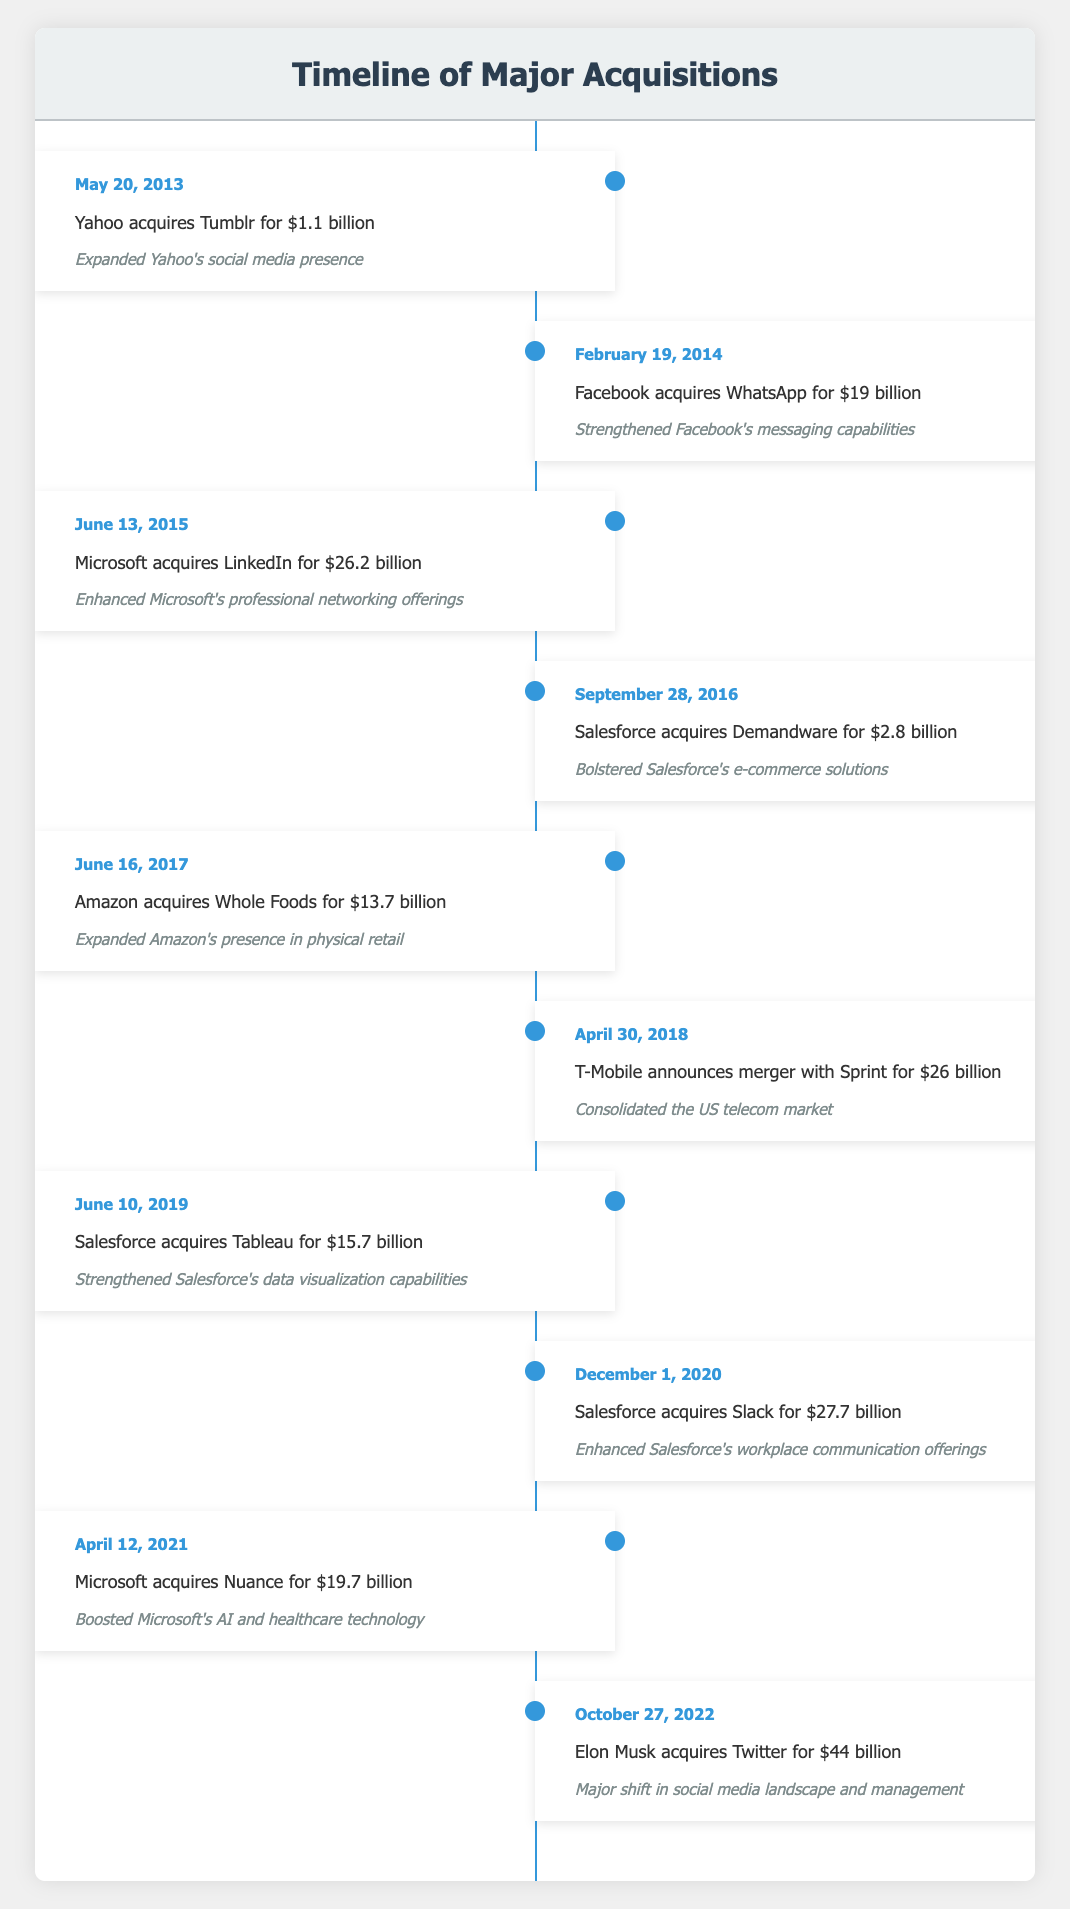What was the highest acquisition value listed in the table? The highest acquisition value is $44 billion, associated with Elon Musk's acquisition of Twitter on October 27, 2022. This information is directly retrieved from the 'event' entry for that specific date.
Answer: $44 billion Which company acquired LinkedIn, and what was the acquisition's date? Microsoft acquired LinkedIn on June 13, 2015. This information can be found by locating the row with LinkedIn in the 'event' column and noting the corresponding 'date' value.
Answer: Microsoft, June 13, 2015 How many acquisitions listed took place in 2020 or later? There are three acquisitions from 2020 onwards: Salesforce acquired Slack for $27.7 billion on December 1, 2020; Microsoft acquired Nuance for $19.7 billion on April 12, 2021; and Elon Musk acquired Twitter for $44 billion on October 27, 2022. Therefore, when counting those instances, the total is three.
Answer: 3 Was there an acquisition by Salesforce that occurred after 2016, and if so, what was it? Yes, Salesforce acquired Tableau for $15.7 billion on June 10, 2019, and Salesforce acquired Slack for $27.7 billion on December 1, 2020. Both of these acquisitions occurred after 2016, confirming the inquiry.
Answer: Yes, Salesforce acquired Tableau and Slack What is the total value of the acquisitions made by Salesforce in the timeline? Adding up the values of the acquisitions made by Salesforce: $2.8 billion (Demandware) + $15.7 billion (Tableau) + $27.7 billion (Slack) = $46.2 billion. This shows the total investment Salesforce made in these three acquisitions based on their listed values.
Answer: $46.2 billion 